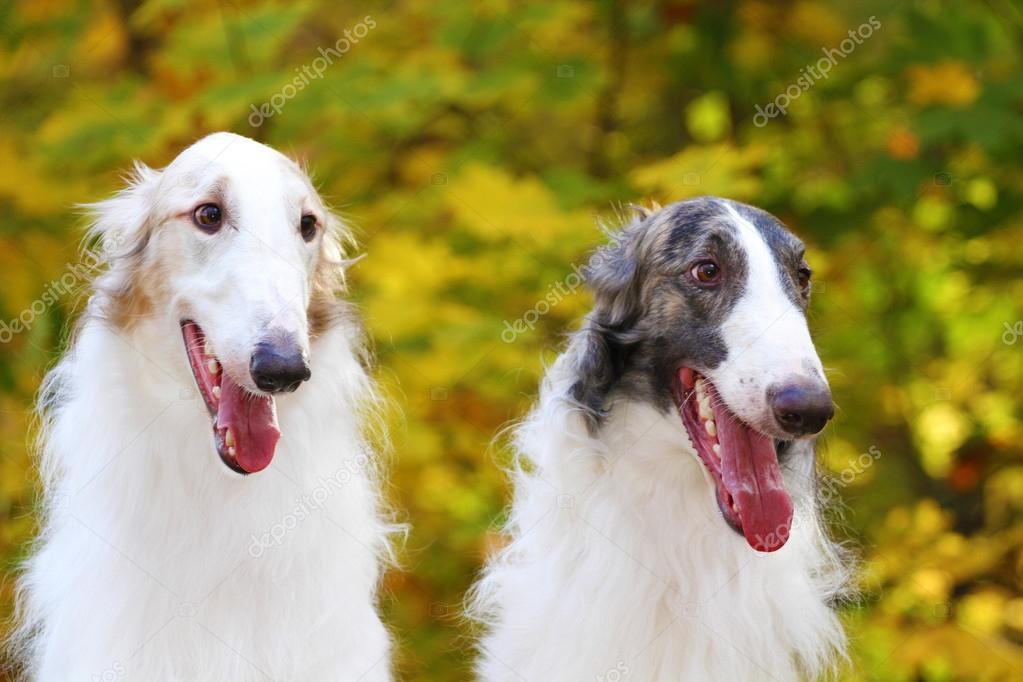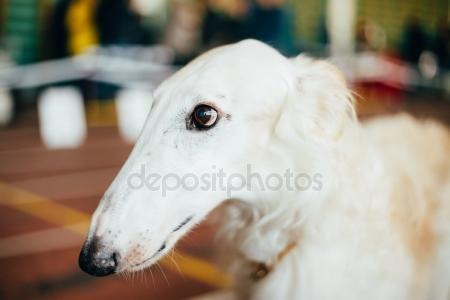The first image is the image on the left, the second image is the image on the right. Assess this claim about the two images: "There are three dogs.". Correct or not? Answer yes or no. Yes. The first image is the image on the left, the second image is the image on the right. Analyze the images presented: Is the assertion "A single dog is lying down in the image on the right." valid? Answer yes or no. No. 